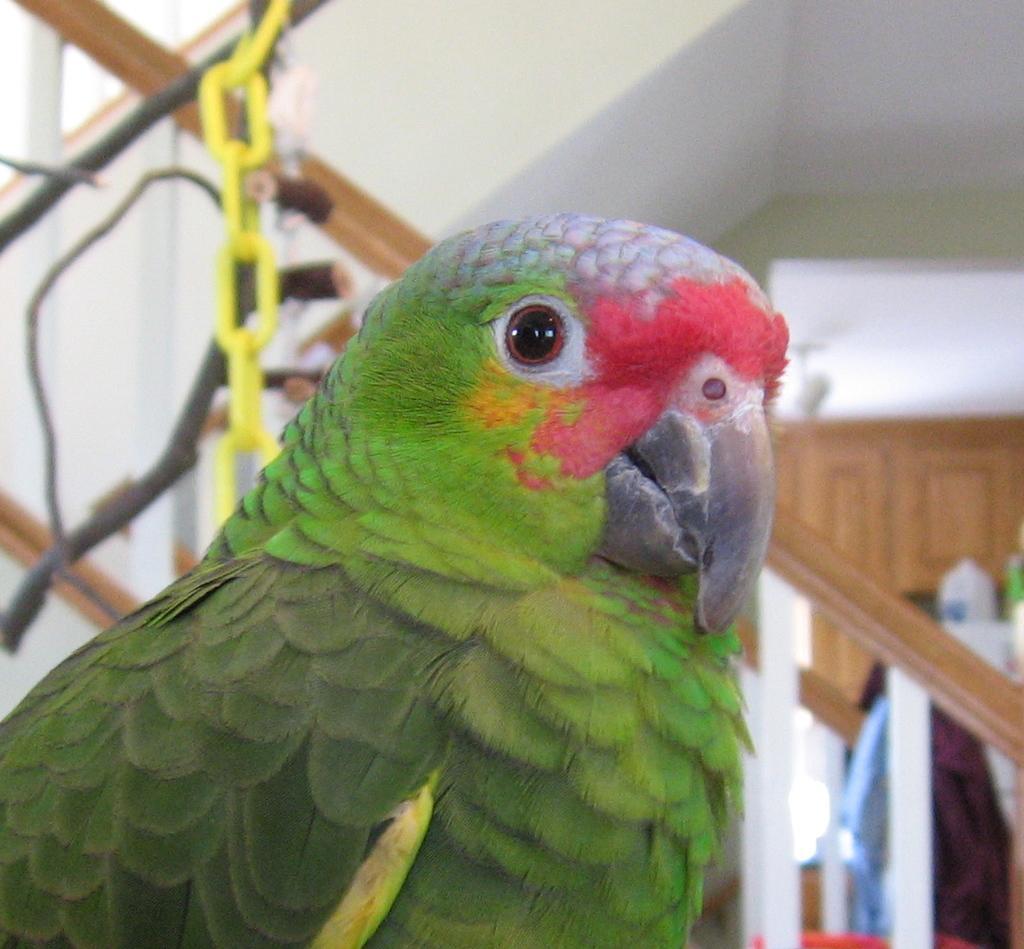Can you describe this image briefly? In the image there is a green parrot in the front and behind there is staircase and over the background there is cupboard on the wall. 